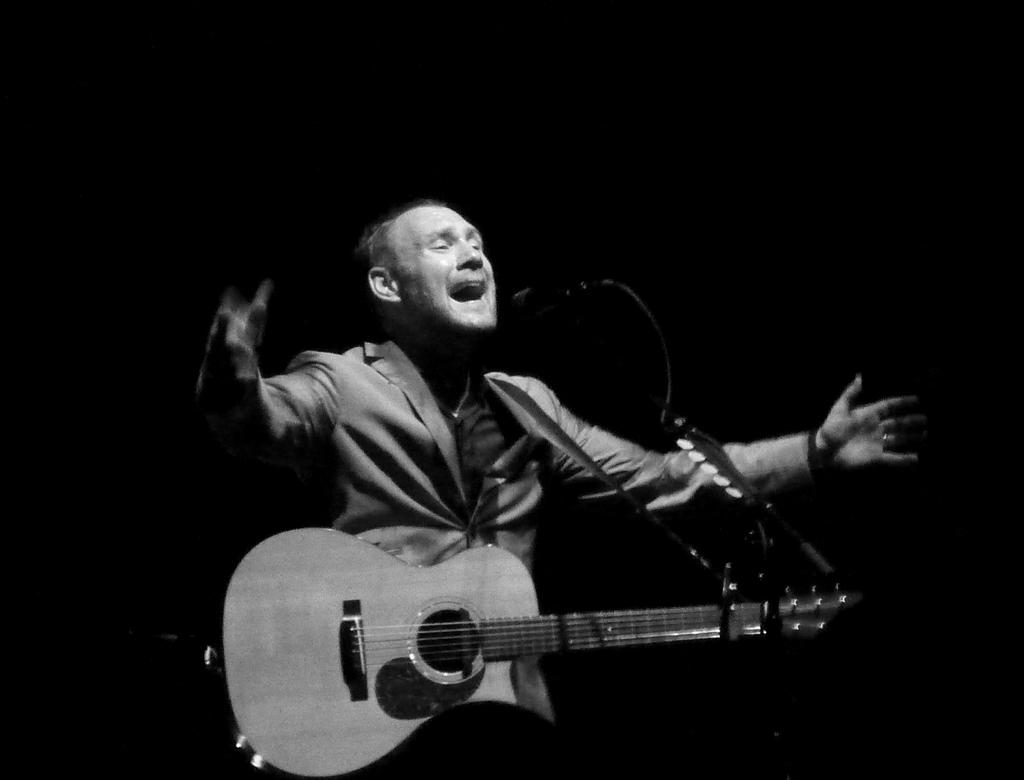What is the man in the image holding? The man is holding a guitar. What is in front of the man? There is a microphone in front of the man. What is the man doing with the guitar? The man is singing while holding the guitar. How is the man positioned with his hands? The man has his hands spread. What type of beam is holding up the ceiling in the image? There is no beam visible in the image, as it appears to be focused on the man and his musical performance. 